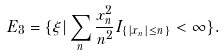Convert formula to latex. <formula><loc_0><loc_0><loc_500><loc_500>E _ { 3 } = \{ \xi | \sum _ { n } \frac { x _ { n } ^ { 2 } } { n ^ { 2 } } I _ { \{ | x _ { n } | \leq n \} } < \infty \} .</formula> 